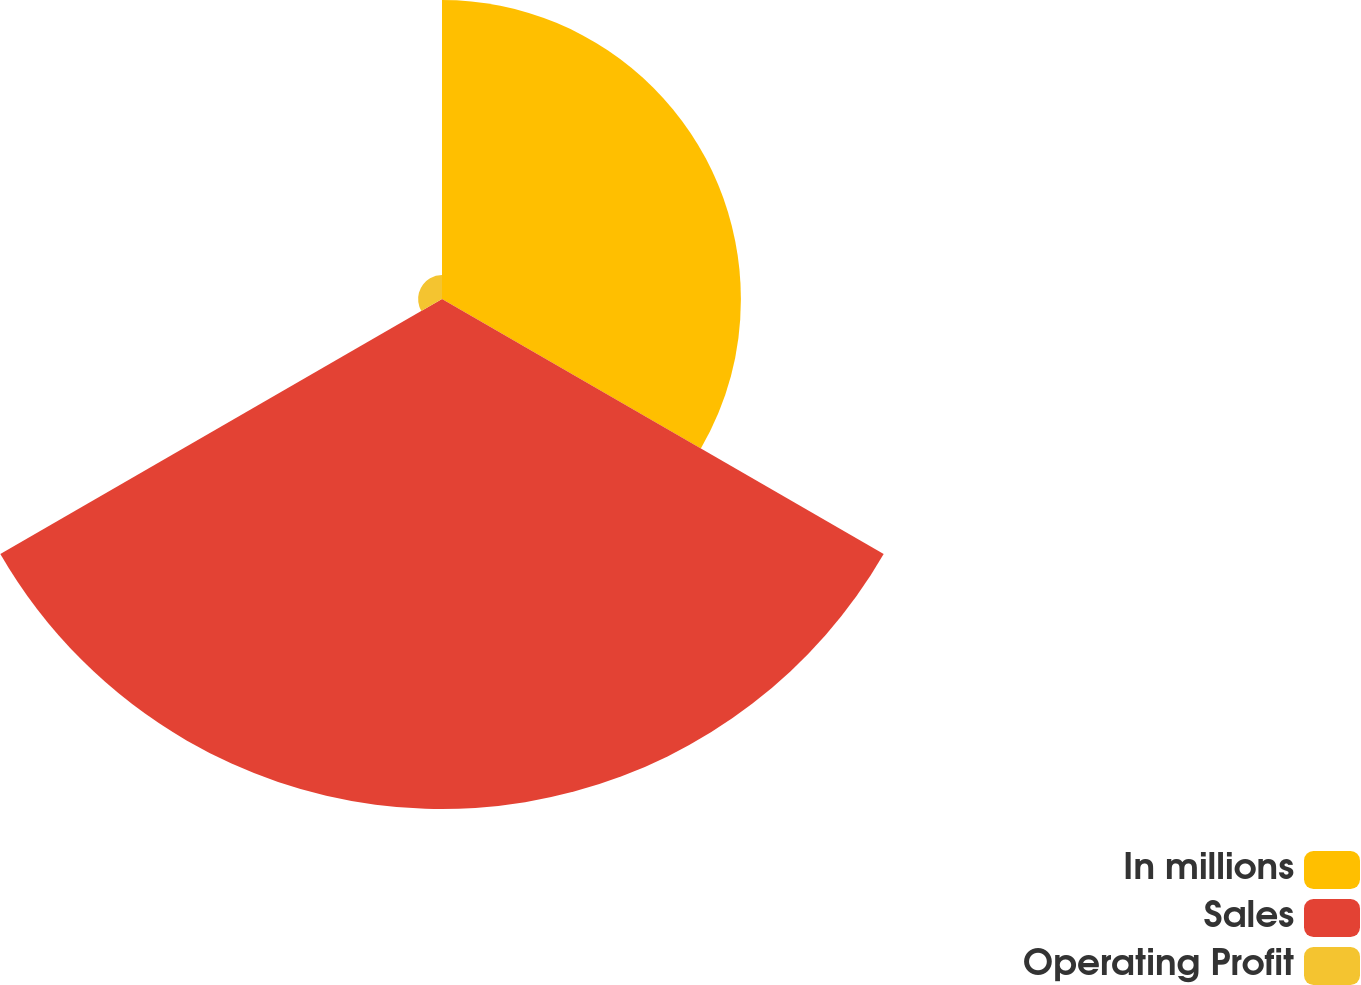<chart> <loc_0><loc_0><loc_500><loc_500><pie_chart><fcel>In millions<fcel>Sales<fcel>Operating Profit<nl><fcel>35.89%<fcel>61.24%<fcel>2.87%<nl></chart> 